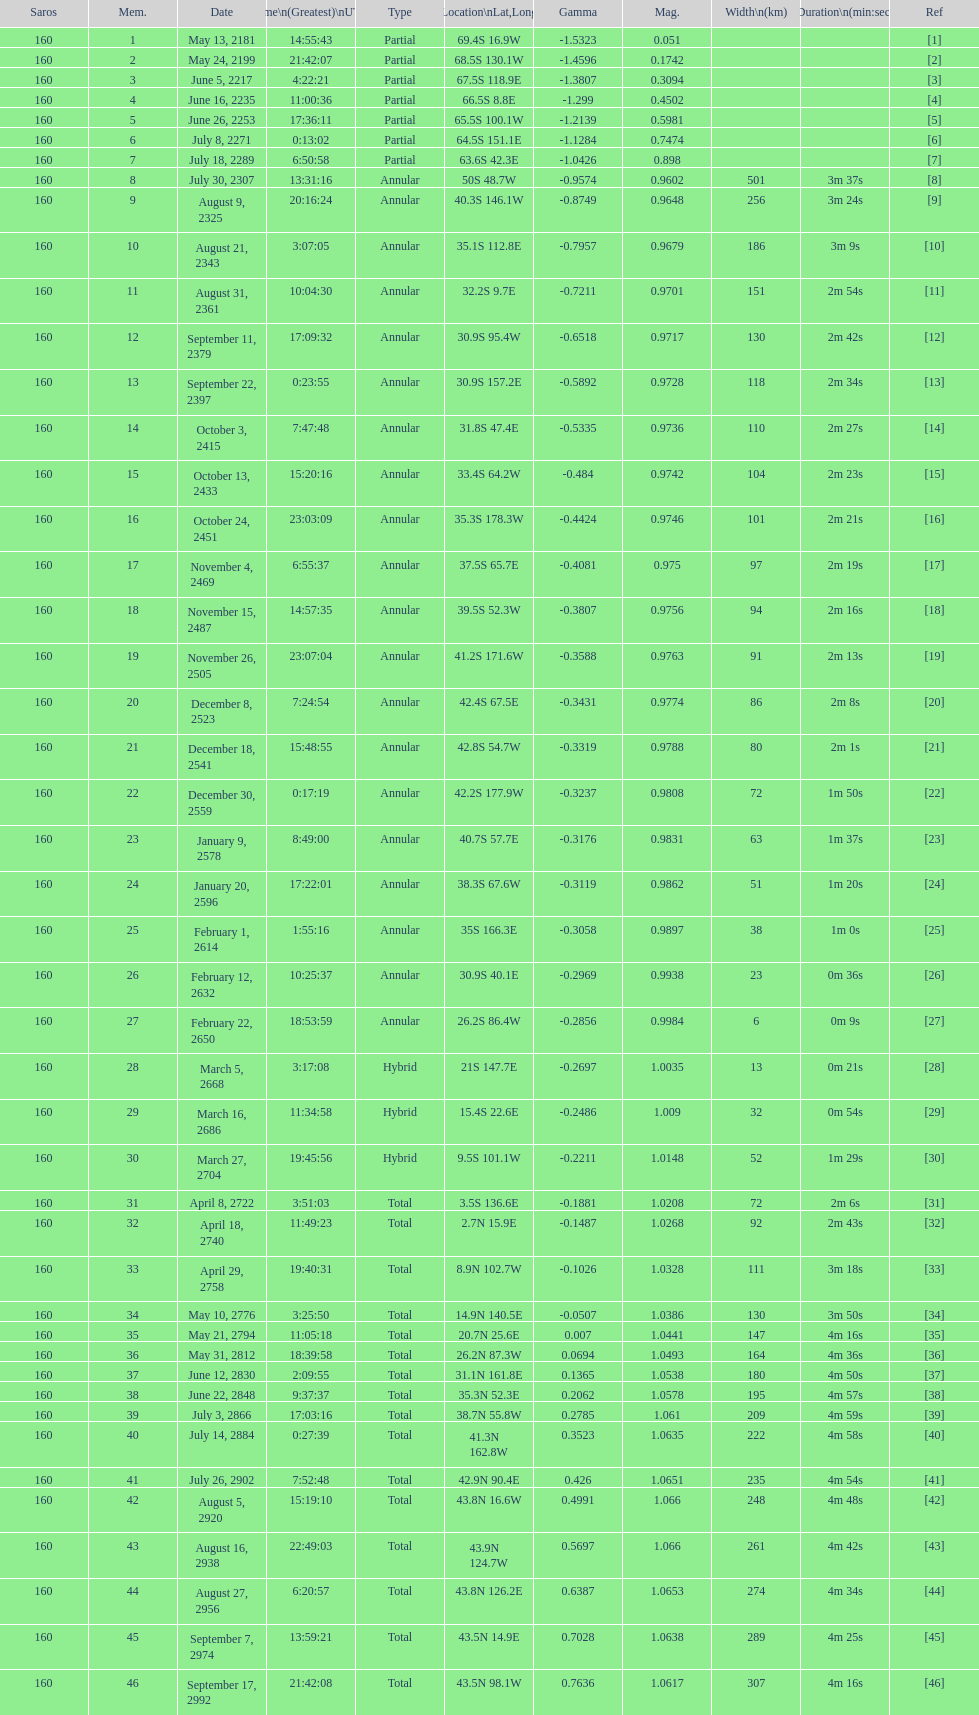When will the next solar saros be after the may 24, 2199 solar saros occurs? June 5, 2217. 